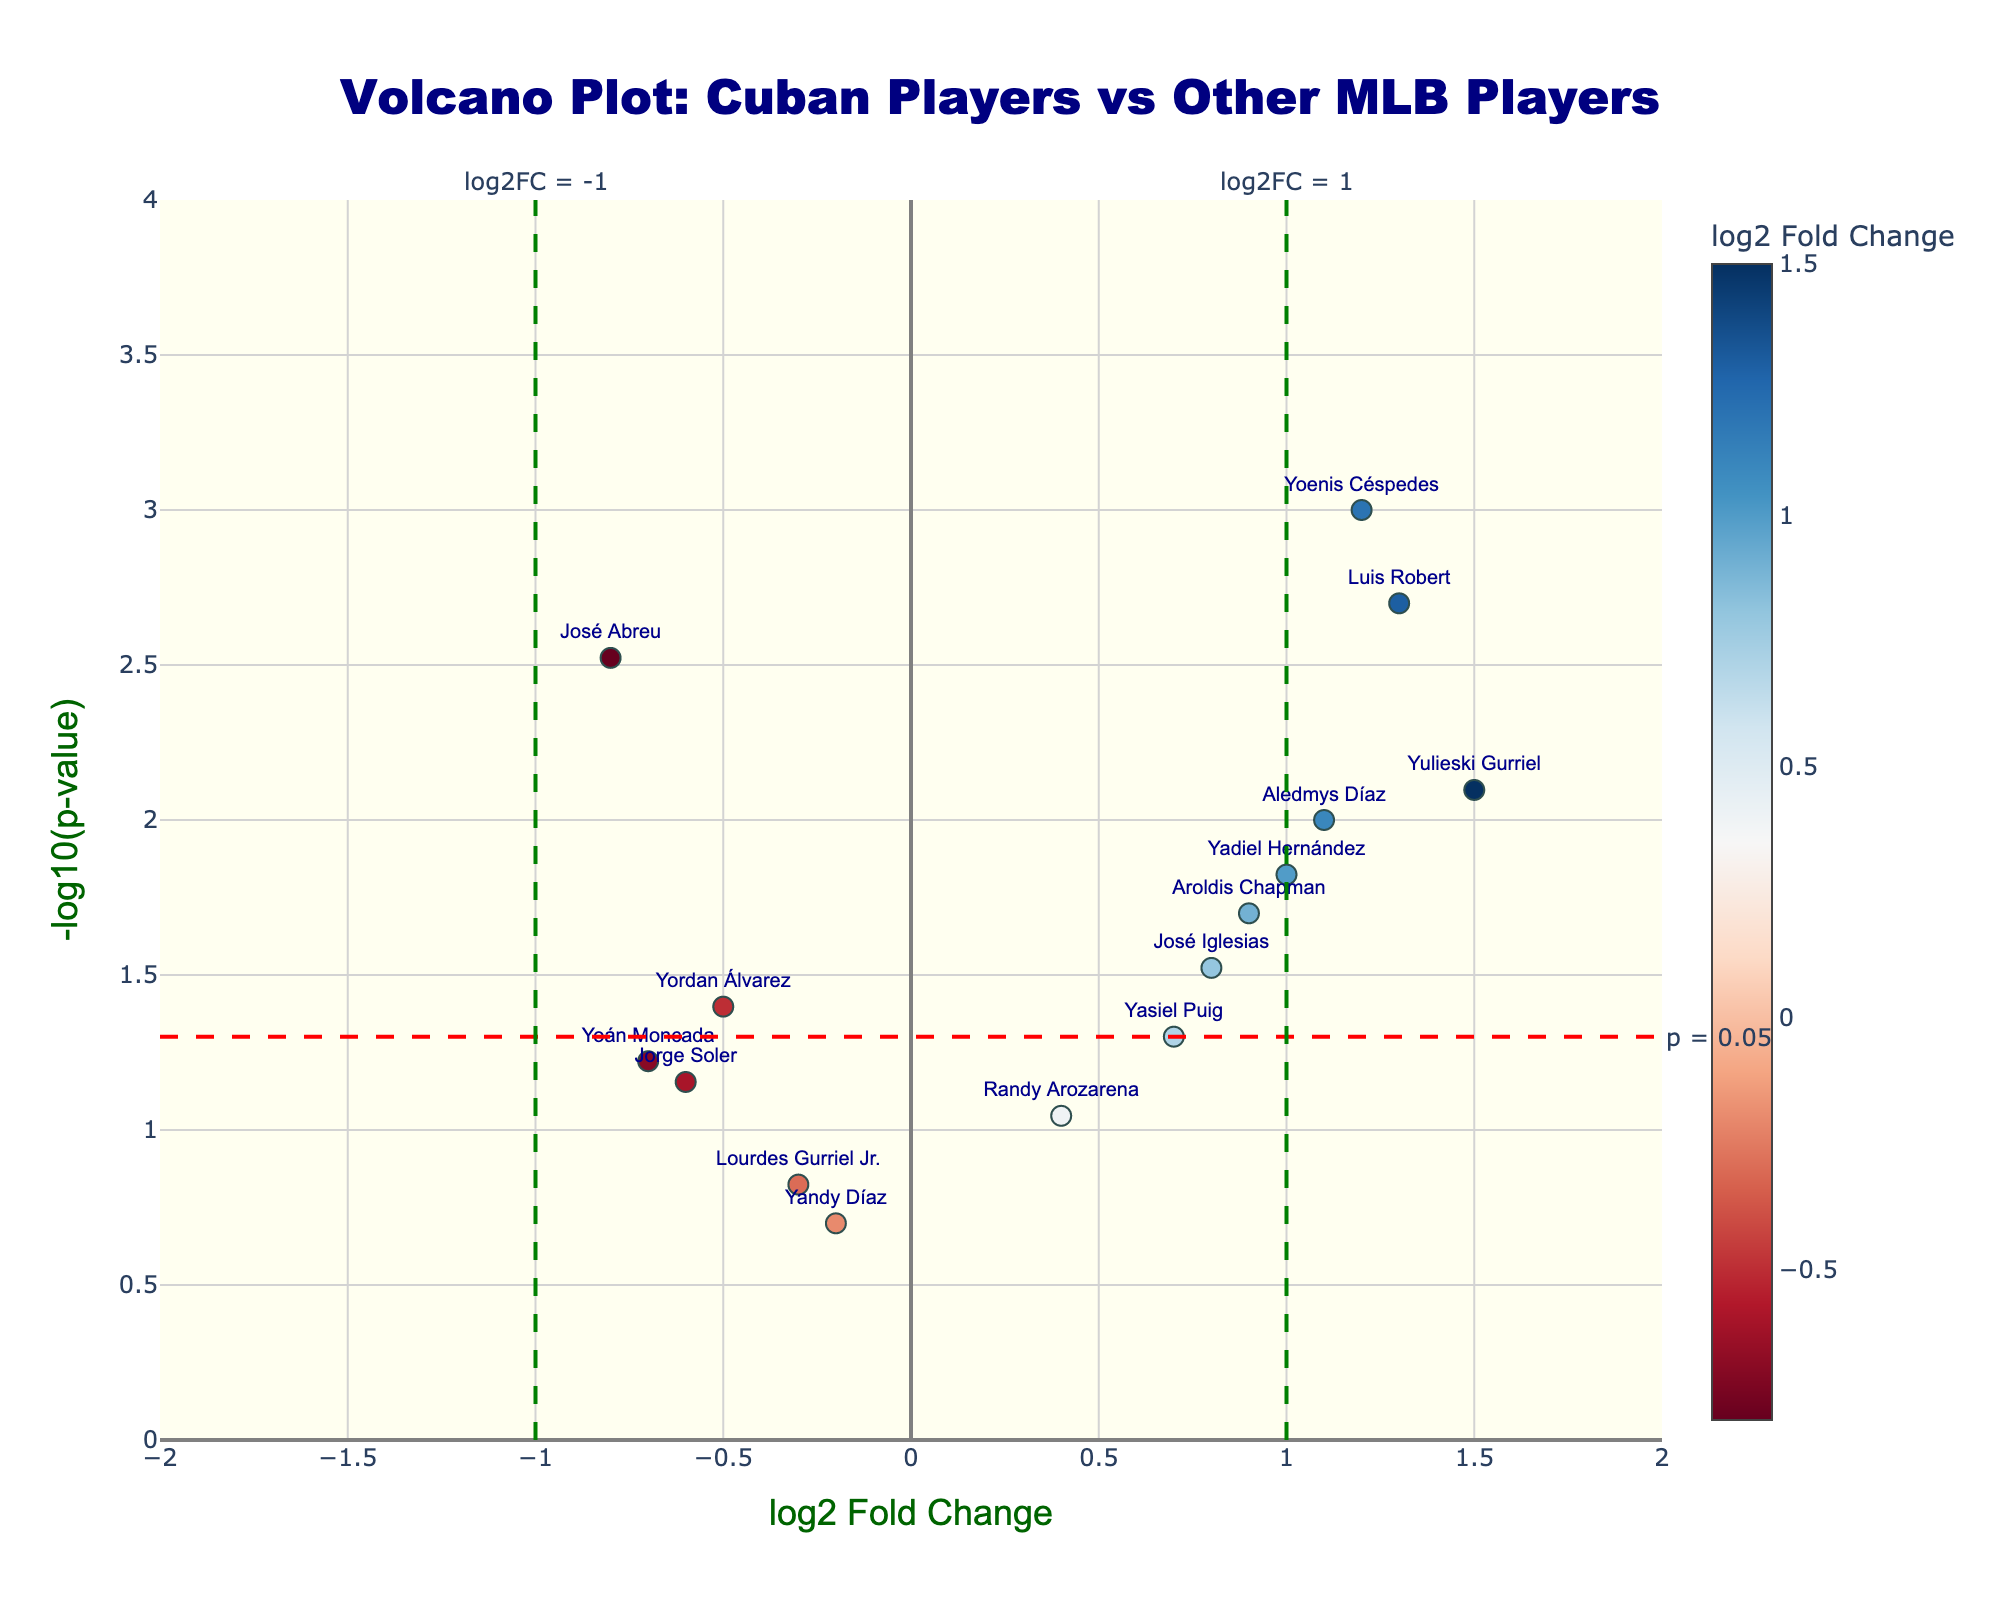How many Cuban players have a log2 Fold Change greater than 1? To find this out, observe the data points in the figure to see which ones lie to the right of the vertical line for log2 Fold Change = 1. These points represent Cuban players with a log2 Fold Change greater than 1.
Answer: 5 What is the log2 Fold Change for the Cuban player with the smallest p-value? First, identify the player with the highest -log10(p-value) since this corresponds to the smallest p-value. This player should be one of the top-most points in the plot. Then, check the log2FoldChange value for this player.
Answer: 1.3 (Luis Robert) Which Cuban player has the highest log2 Fold Change? Look for the data point that is furthest to the right on the horizontal axis. The label of this point will tell you the player with the highest log2 Fold Change.
Answer: Yulieski Gurriel What is the p-value threshold used in the plot? Locate the horizontal dashed line on the plot. The annotation next to this line indicates the p-value threshold.
Answer: 0.05 Are there any Cuban players with significant p-values (p < 0.05) but negative log2 Fold Changes? Look for data points that are both below the log2 Fold Change = 0 line (indicating a negative log2 Fold Change) and above the -log10(p-value) = 1.3 line (indicating a p-value < 0.05).
Answer: Yes, José Abreu Compare the log2 Fold Changes of Lourdes Gurriel Jr. and Aroldis Chapman. Which one is higher? Locate the points corresponding to these two players and compare their positions along the horizontal axis (log2 Fold Change).
Answer: Aroldis Chapman How many Cuban players have non-significant p-values (p ≥ 0.05)? Count the data points that lie below the -log10(p-value) = 1.3 line. These points represent Cuban players with non-significant p-values.
Answer: 5 (Lourdes Gurriel Jr., Yasiel Puig, Jorge Soler, Randy Arozarena, Yandy Díaz) What is the range of -log10(p-values) displayed in the plot? Examine the y-axis of the plot to determine the minimum and maximum values shown for -log10(p-value).
Answer: 0 to 4 Which Cuban player has the lowest log2 Fold Change? Find the data point that is furthest to the left on the horizontal axis. The label of this point will tell you the player with the lowest log2 Fold Change.
Answer: José Abreu How many Cuban players have both a log2 Fold Change above 0 and a p-value less than 0.05? Look for data points that lie to the right of the log2 Fold Change = 0 line (indicating a positive log2 Fold Change) and above the -log10(p-value) = 1.3 line (indicating a p-value < 0.05).
Answer: 6 